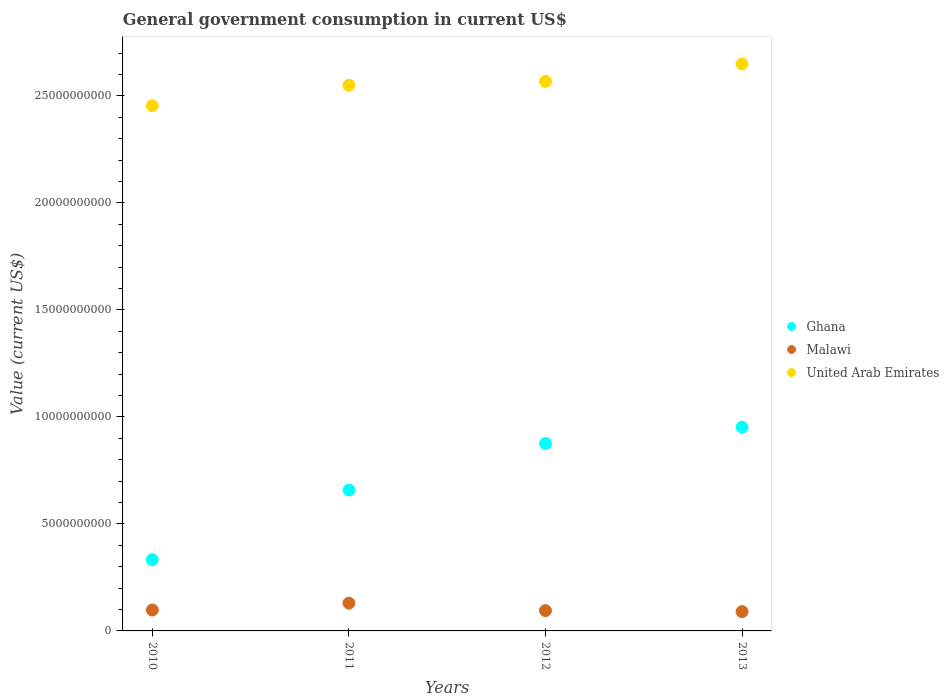How many different coloured dotlines are there?
Offer a terse response. 3. What is the government conusmption in Malawi in 2012?
Your answer should be compact. 9.49e+08. Across all years, what is the maximum government conusmption in United Arab Emirates?
Ensure brevity in your answer.  2.65e+1. Across all years, what is the minimum government conusmption in Malawi?
Make the answer very short. 9.03e+08. In which year was the government conusmption in United Arab Emirates maximum?
Your answer should be compact. 2013. What is the total government conusmption in Ghana in the graph?
Your answer should be compact. 2.82e+1. What is the difference between the government conusmption in Ghana in 2010 and that in 2011?
Give a very brief answer. -3.25e+09. What is the difference between the government conusmption in United Arab Emirates in 2013 and the government conusmption in Malawi in 2012?
Ensure brevity in your answer.  2.55e+1. What is the average government conusmption in Ghana per year?
Keep it short and to the point. 7.05e+09. In the year 2012, what is the difference between the government conusmption in Ghana and government conusmption in Malawi?
Provide a short and direct response. 7.81e+09. What is the ratio of the government conusmption in Ghana in 2010 to that in 2011?
Your response must be concise. 0.51. Is the government conusmption in United Arab Emirates in 2011 less than that in 2013?
Provide a short and direct response. Yes. Is the difference between the government conusmption in Ghana in 2010 and 2012 greater than the difference between the government conusmption in Malawi in 2010 and 2012?
Ensure brevity in your answer.  No. What is the difference between the highest and the second highest government conusmption in United Arab Emirates?
Make the answer very short. 8.16e+08. What is the difference between the highest and the lowest government conusmption in Malawi?
Make the answer very short. 3.94e+08. In how many years, is the government conusmption in Ghana greater than the average government conusmption in Ghana taken over all years?
Your answer should be compact. 2. Is it the case that in every year, the sum of the government conusmption in Malawi and government conusmption in United Arab Emirates  is greater than the government conusmption in Ghana?
Ensure brevity in your answer.  Yes. How many dotlines are there?
Your response must be concise. 3. Are the values on the major ticks of Y-axis written in scientific E-notation?
Provide a succinct answer. No. Does the graph contain grids?
Keep it short and to the point. No. How many legend labels are there?
Give a very brief answer. 3. What is the title of the graph?
Offer a very short reply. General government consumption in current US$. What is the label or title of the X-axis?
Your answer should be compact. Years. What is the label or title of the Y-axis?
Give a very brief answer. Value (current US$). What is the Value (current US$) in Ghana in 2010?
Your answer should be very brief. 3.33e+09. What is the Value (current US$) in Malawi in 2010?
Your response must be concise. 9.76e+08. What is the Value (current US$) of United Arab Emirates in 2010?
Give a very brief answer. 2.45e+1. What is the Value (current US$) in Ghana in 2011?
Make the answer very short. 6.59e+09. What is the Value (current US$) in Malawi in 2011?
Ensure brevity in your answer.  1.30e+09. What is the Value (current US$) in United Arab Emirates in 2011?
Your response must be concise. 2.55e+1. What is the Value (current US$) in Ghana in 2012?
Provide a short and direct response. 8.76e+09. What is the Value (current US$) in Malawi in 2012?
Your answer should be compact. 9.49e+08. What is the Value (current US$) of United Arab Emirates in 2012?
Your response must be concise. 2.57e+1. What is the Value (current US$) in Ghana in 2013?
Your response must be concise. 9.52e+09. What is the Value (current US$) in Malawi in 2013?
Give a very brief answer. 9.03e+08. What is the Value (current US$) in United Arab Emirates in 2013?
Offer a terse response. 2.65e+1. Across all years, what is the maximum Value (current US$) of Ghana?
Make the answer very short. 9.52e+09. Across all years, what is the maximum Value (current US$) in Malawi?
Provide a short and direct response. 1.30e+09. Across all years, what is the maximum Value (current US$) of United Arab Emirates?
Keep it short and to the point. 2.65e+1. Across all years, what is the minimum Value (current US$) in Ghana?
Your answer should be compact. 3.33e+09. Across all years, what is the minimum Value (current US$) in Malawi?
Give a very brief answer. 9.03e+08. Across all years, what is the minimum Value (current US$) in United Arab Emirates?
Give a very brief answer. 2.45e+1. What is the total Value (current US$) of Ghana in the graph?
Keep it short and to the point. 2.82e+1. What is the total Value (current US$) of Malawi in the graph?
Your answer should be compact. 4.13e+09. What is the total Value (current US$) in United Arab Emirates in the graph?
Your response must be concise. 1.02e+11. What is the difference between the Value (current US$) of Ghana in 2010 and that in 2011?
Offer a terse response. -3.25e+09. What is the difference between the Value (current US$) of Malawi in 2010 and that in 2011?
Offer a terse response. -3.21e+08. What is the difference between the Value (current US$) in United Arab Emirates in 2010 and that in 2011?
Provide a short and direct response. -9.57e+08. What is the difference between the Value (current US$) of Ghana in 2010 and that in 2012?
Offer a terse response. -5.43e+09. What is the difference between the Value (current US$) in Malawi in 2010 and that in 2012?
Give a very brief answer. 2.67e+07. What is the difference between the Value (current US$) in United Arab Emirates in 2010 and that in 2012?
Your answer should be compact. -1.14e+09. What is the difference between the Value (current US$) in Ghana in 2010 and that in 2013?
Give a very brief answer. -6.19e+09. What is the difference between the Value (current US$) in Malawi in 2010 and that in 2013?
Your answer should be very brief. 7.27e+07. What is the difference between the Value (current US$) in United Arab Emirates in 2010 and that in 2013?
Ensure brevity in your answer.  -1.95e+09. What is the difference between the Value (current US$) of Ghana in 2011 and that in 2012?
Ensure brevity in your answer.  -2.18e+09. What is the difference between the Value (current US$) of Malawi in 2011 and that in 2012?
Provide a short and direct response. 3.48e+08. What is the difference between the Value (current US$) of United Arab Emirates in 2011 and that in 2012?
Your answer should be compact. -1.78e+08. What is the difference between the Value (current US$) in Ghana in 2011 and that in 2013?
Provide a succinct answer. -2.94e+09. What is the difference between the Value (current US$) of Malawi in 2011 and that in 2013?
Make the answer very short. 3.94e+08. What is the difference between the Value (current US$) in United Arab Emirates in 2011 and that in 2013?
Your answer should be compact. -9.94e+08. What is the difference between the Value (current US$) of Ghana in 2012 and that in 2013?
Your answer should be compact. -7.61e+08. What is the difference between the Value (current US$) in Malawi in 2012 and that in 2013?
Ensure brevity in your answer.  4.60e+07. What is the difference between the Value (current US$) in United Arab Emirates in 2012 and that in 2013?
Provide a succinct answer. -8.16e+08. What is the difference between the Value (current US$) in Ghana in 2010 and the Value (current US$) in Malawi in 2011?
Your answer should be compact. 2.03e+09. What is the difference between the Value (current US$) of Ghana in 2010 and the Value (current US$) of United Arab Emirates in 2011?
Offer a terse response. -2.22e+1. What is the difference between the Value (current US$) in Malawi in 2010 and the Value (current US$) in United Arab Emirates in 2011?
Offer a very short reply. -2.45e+1. What is the difference between the Value (current US$) in Ghana in 2010 and the Value (current US$) in Malawi in 2012?
Make the answer very short. 2.38e+09. What is the difference between the Value (current US$) of Ghana in 2010 and the Value (current US$) of United Arab Emirates in 2012?
Keep it short and to the point. -2.23e+1. What is the difference between the Value (current US$) in Malawi in 2010 and the Value (current US$) in United Arab Emirates in 2012?
Your answer should be compact. -2.47e+1. What is the difference between the Value (current US$) in Ghana in 2010 and the Value (current US$) in Malawi in 2013?
Provide a succinct answer. 2.43e+09. What is the difference between the Value (current US$) of Ghana in 2010 and the Value (current US$) of United Arab Emirates in 2013?
Offer a very short reply. -2.32e+1. What is the difference between the Value (current US$) in Malawi in 2010 and the Value (current US$) in United Arab Emirates in 2013?
Your answer should be very brief. -2.55e+1. What is the difference between the Value (current US$) in Ghana in 2011 and the Value (current US$) in Malawi in 2012?
Give a very brief answer. 5.64e+09. What is the difference between the Value (current US$) of Ghana in 2011 and the Value (current US$) of United Arab Emirates in 2012?
Ensure brevity in your answer.  -1.91e+1. What is the difference between the Value (current US$) of Malawi in 2011 and the Value (current US$) of United Arab Emirates in 2012?
Provide a short and direct response. -2.44e+1. What is the difference between the Value (current US$) in Ghana in 2011 and the Value (current US$) in Malawi in 2013?
Offer a terse response. 5.68e+09. What is the difference between the Value (current US$) of Ghana in 2011 and the Value (current US$) of United Arab Emirates in 2013?
Offer a terse response. -1.99e+1. What is the difference between the Value (current US$) of Malawi in 2011 and the Value (current US$) of United Arab Emirates in 2013?
Your answer should be very brief. -2.52e+1. What is the difference between the Value (current US$) of Ghana in 2012 and the Value (current US$) of Malawi in 2013?
Make the answer very short. 7.86e+09. What is the difference between the Value (current US$) in Ghana in 2012 and the Value (current US$) in United Arab Emirates in 2013?
Ensure brevity in your answer.  -1.77e+1. What is the difference between the Value (current US$) in Malawi in 2012 and the Value (current US$) in United Arab Emirates in 2013?
Offer a terse response. -2.55e+1. What is the average Value (current US$) in Ghana per year?
Provide a short and direct response. 7.05e+09. What is the average Value (current US$) of Malawi per year?
Your response must be concise. 1.03e+09. What is the average Value (current US$) of United Arab Emirates per year?
Provide a succinct answer. 2.56e+1. In the year 2010, what is the difference between the Value (current US$) in Ghana and Value (current US$) in Malawi?
Provide a succinct answer. 2.36e+09. In the year 2010, what is the difference between the Value (current US$) in Ghana and Value (current US$) in United Arab Emirates?
Offer a terse response. -2.12e+1. In the year 2010, what is the difference between the Value (current US$) in Malawi and Value (current US$) in United Arab Emirates?
Keep it short and to the point. -2.36e+1. In the year 2011, what is the difference between the Value (current US$) of Ghana and Value (current US$) of Malawi?
Your answer should be compact. 5.29e+09. In the year 2011, what is the difference between the Value (current US$) in Ghana and Value (current US$) in United Arab Emirates?
Make the answer very short. -1.89e+1. In the year 2011, what is the difference between the Value (current US$) of Malawi and Value (current US$) of United Arab Emirates?
Offer a terse response. -2.42e+1. In the year 2012, what is the difference between the Value (current US$) of Ghana and Value (current US$) of Malawi?
Provide a short and direct response. 7.81e+09. In the year 2012, what is the difference between the Value (current US$) of Ghana and Value (current US$) of United Arab Emirates?
Make the answer very short. -1.69e+1. In the year 2012, what is the difference between the Value (current US$) of Malawi and Value (current US$) of United Arab Emirates?
Offer a terse response. -2.47e+1. In the year 2013, what is the difference between the Value (current US$) in Ghana and Value (current US$) in Malawi?
Make the answer very short. 8.62e+09. In the year 2013, what is the difference between the Value (current US$) in Ghana and Value (current US$) in United Arab Emirates?
Ensure brevity in your answer.  -1.70e+1. In the year 2013, what is the difference between the Value (current US$) in Malawi and Value (current US$) in United Arab Emirates?
Your answer should be very brief. -2.56e+1. What is the ratio of the Value (current US$) in Ghana in 2010 to that in 2011?
Provide a short and direct response. 0.51. What is the ratio of the Value (current US$) of Malawi in 2010 to that in 2011?
Provide a short and direct response. 0.75. What is the ratio of the Value (current US$) in United Arab Emirates in 2010 to that in 2011?
Your response must be concise. 0.96. What is the ratio of the Value (current US$) of Ghana in 2010 to that in 2012?
Your answer should be very brief. 0.38. What is the ratio of the Value (current US$) of Malawi in 2010 to that in 2012?
Provide a succinct answer. 1.03. What is the ratio of the Value (current US$) of United Arab Emirates in 2010 to that in 2012?
Your response must be concise. 0.96. What is the ratio of the Value (current US$) of Ghana in 2010 to that in 2013?
Your response must be concise. 0.35. What is the ratio of the Value (current US$) of Malawi in 2010 to that in 2013?
Make the answer very short. 1.08. What is the ratio of the Value (current US$) of United Arab Emirates in 2010 to that in 2013?
Ensure brevity in your answer.  0.93. What is the ratio of the Value (current US$) in Ghana in 2011 to that in 2012?
Offer a terse response. 0.75. What is the ratio of the Value (current US$) in Malawi in 2011 to that in 2012?
Ensure brevity in your answer.  1.37. What is the ratio of the Value (current US$) of Ghana in 2011 to that in 2013?
Your answer should be very brief. 0.69. What is the ratio of the Value (current US$) of Malawi in 2011 to that in 2013?
Offer a terse response. 1.44. What is the ratio of the Value (current US$) in United Arab Emirates in 2011 to that in 2013?
Provide a succinct answer. 0.96. What is the ratio of the Value (current US$) in Malawi in 2012 to that in 2013?
Offer a terse response. 1.05. What is the ratio of the Value (current US$) of United Arab Emirates in 2012 to that in 2013?
Your answer should be very brief. 0.97. What is the difference between the highest and the second highest Value (current US$) in Ghana?
Provide a succinct answer. 7.61e+08. What is the difference between the highest and the second highest Value (current US$) of Malawi?
Your response must be concise. 3.21e+08. What is the difference between the highest and the second highest Value (current US$) in United Arab Emirates?
Your answer should be compact. 8.16e+08. What is the difference between the highest and the lowest Value (current US$) of Ghana?
Ensure brevity in your answer.  6.19e+09. What is the difference between the highest and the lowest Value (current US$) of Malawi?
Give a very brief answer. 3.94e+08. What is the difference between the highest and the lowest Value (current US$) in United Arab Emirates?
Offer a terse response. 1.95e+09. 